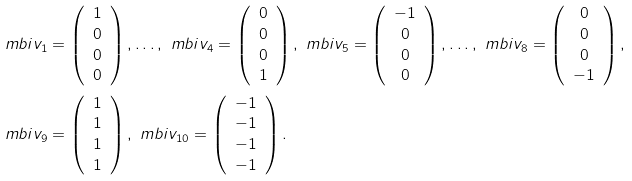<formula> <loc_0><loc_0><loc_500><loc_500>\ m b i v _ { 1 } & = \left ( \begin{array} { c c } 1 \\ 0 \\ 0 \\ 0 \end{array} \right ) , \dots , \ m b i v _ { 4 } = \left ( \begin{array} { c c } 0 \\ 0 \\ 0 \\ 1 \end{array} \right ) , \ m b i v _ { 5 } = \left ( \begin{array} { c c } - 1 \\ 0 \\ 0 \\ 0 \end{array} \right ) , \dots , \ m b i v _ { 8 } = \left ( \begin{array} { c c } 0 \\ 0 \\ 0 \\ - 1 \end{array} \right ) , \\ \ m b i v _ { 9 } & = \left ( \begin{array} { c c } 1 \\ 1 \\ 1 \\ 1 \end{array} \right ) , \ m b i v _ { 1 0 } = \left ( \begin{array} { c c } - 1 \\ - 1 \\ - 1 \\ - 1 \end{array} \right ) .</formula> 